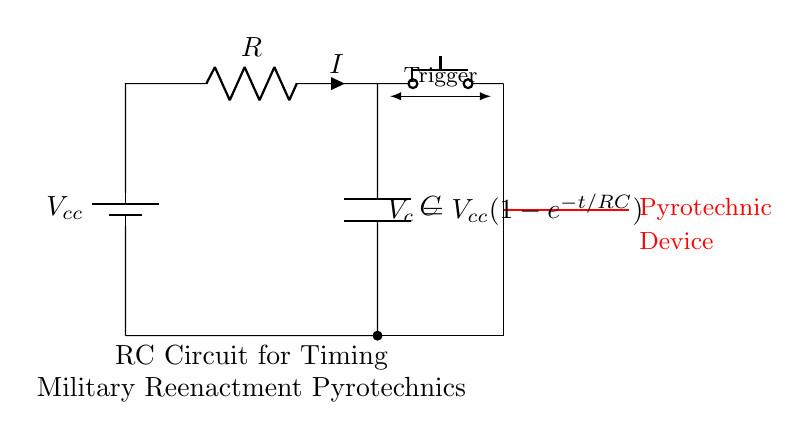What type of components are in this circuit? The circuit consists of a battery, resistor, capacitor, and a push button switch. These components are standard in an RC circuit used for timing applications.
Answer: battery, resistor, capacitor, push button switch What does the battery provide? The battery supplies the voltage to the circuit, which is necessary for the operation of the resistor-capacitor components.
Answer: voltage What is the function of the push button switch? The push button switch acts as a trigger to start the timing sequence in the RC circuit, allowing the capacitor to charge and discharge to activate the pyrotechnic device.
Answer: trigger How is the voltage across the capacitor expressed? The voltage across the capacitor as a function of time is given by the equation V_c = V_cc(1-e^{-t/RC}), where V_cc is the supply voltage, t is time, and R and C are the resistor and capacitor values.
Answer: V_c = V_cc(1-e^{-t/RC}) What will happen when the push button is pressed? When the push button is pressed, it completes the circuit to allow current to flow through the resistor and charge the capacitor, which will eventually reach a voltage that activates the pyrotechnic device.
Answer: charges the capacitor What is the significance of the resistor and capacitor values? The resistor and capacitor values determine the time constant (τ = RC) of the circuit, influencing how quickly the voltage across the capacitor rises and thus how long it takes for the pyrotechnic device to be triggered.
Answer: timing constant 